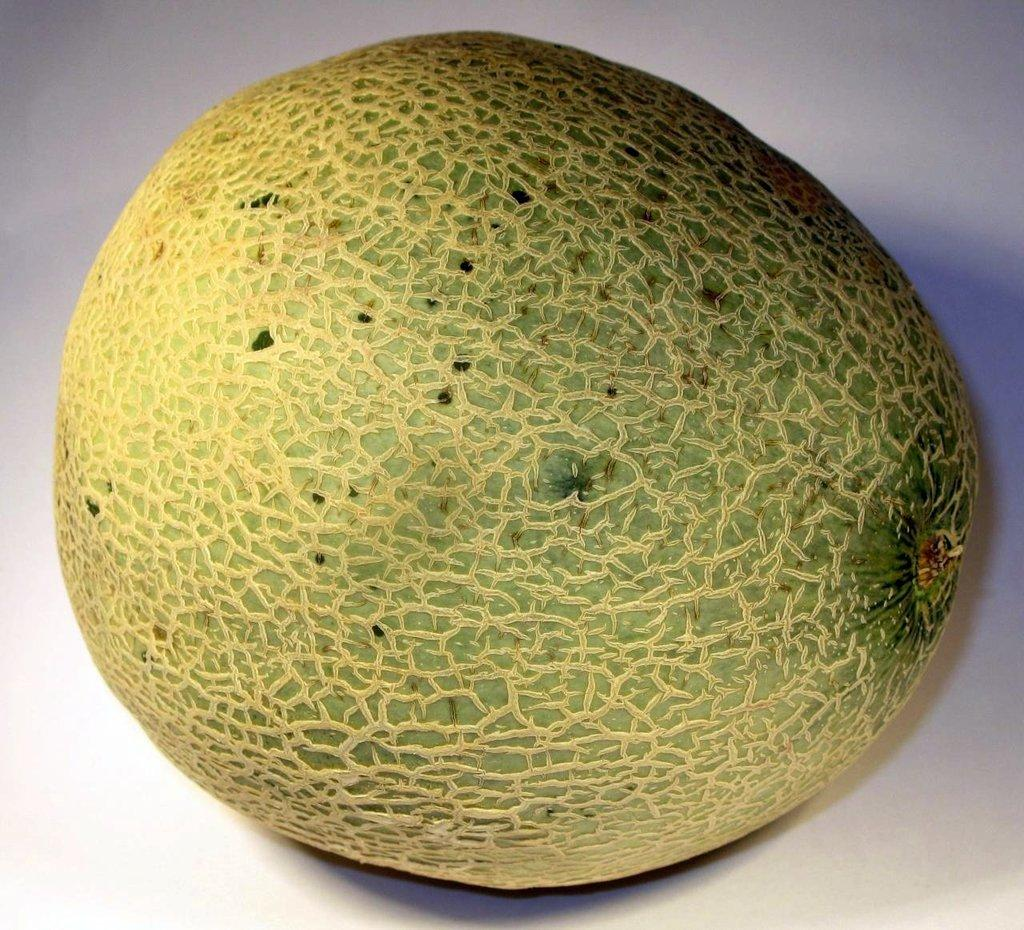What type of food item is present in the image? There is a fruit in the image. On what surface is the fruit placed? The fruit is on a white surface. What color is the background of the image? The background of the image is white. Can you see any wounds on the fruit in the image? There is no indication of any wounds on the fruit in the image. Is there a tent visible in the image? There is no tent present in the image. 